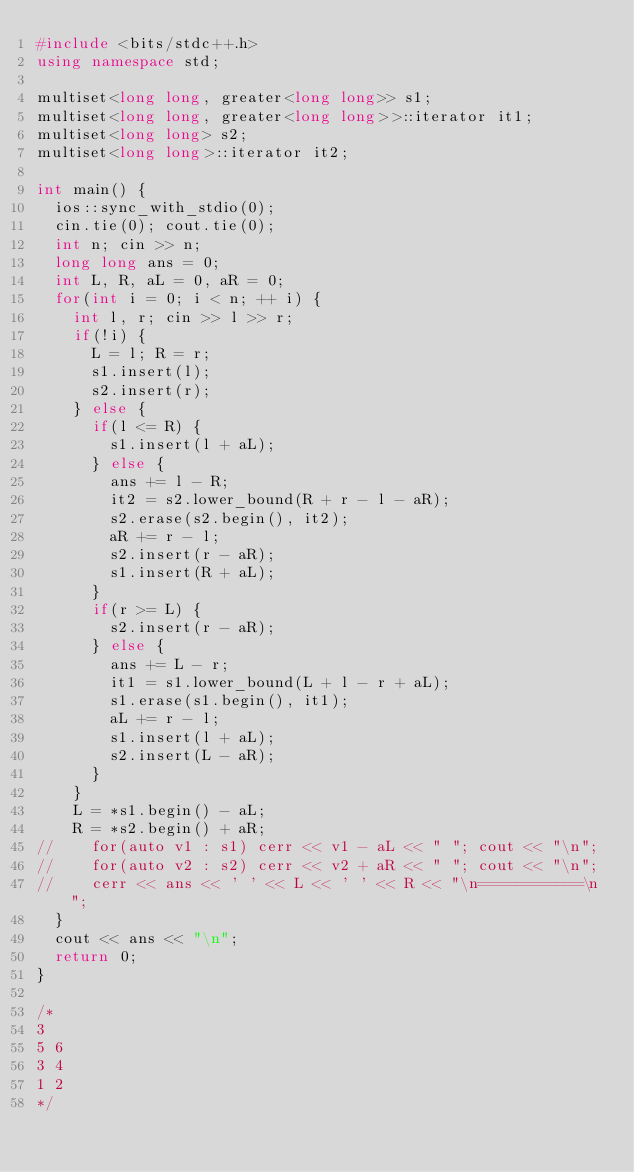<code> <loc_0><loc_0><loc_500><loc_500><_C++_>#include <bits/stdc++.h>
using namespace std;

multiset<long long, greater<long long>> s1;
multiset<long long, greater<long long>>::iterator it1;
multiset<long long> s2;
multiset<long long>::iterator it2;

int main() {
	ios::sync_with_stdio(0);
	cin.tie(0); cout.tie(0);
	int n; cin >> n;
	long long ans = 0;
	int L, R, aL = 0, aR = 0;
	for(int i = 0; i < n; ++ i) {
		int l, r; cin >> l >> r;
		if(!i) {
			L = l; R = r;
			s1.insert(l);
			s2.insert(r);
		} else {
			if(l <= R) {
				s1.insert(l + aL);	
			} else {
				ans += l - R;
				it2 = s2.lower_bound(R + r - l - aR);
				s2.erase(s2.begin(), it2);
				aR += r - l;
				s2.insert(r - aR);
				s1.insert(R + aL);
			}
			if(r >= L) {
				s2.insert(r - aR);
			} else {
				ans += L - r;
				it1 = s1.lower_bound(L + l - r + aL);
				s1.erase(s1.begin(), it1);
				aL += r - l;
				s1.insert(l + aL);
				s2.insert(L - aR);
			}
		}
		L = *s1.begin() - aL;
		R = *s2.begin() + aR;
//		for(auto v1 : s1) cerr << v1 - aL << " "; cout << "\n";
//		for(auto v2 : s2) cerr << v2 + aR << " "; cout << "\n";
//		cerr << ans << ' ' << L << ' ' << R << "\n===========\n";
	}
	cout << ans << "\n";
	return 0;
}

/*
3
5 6
3 4
1 2
*/
</code> 